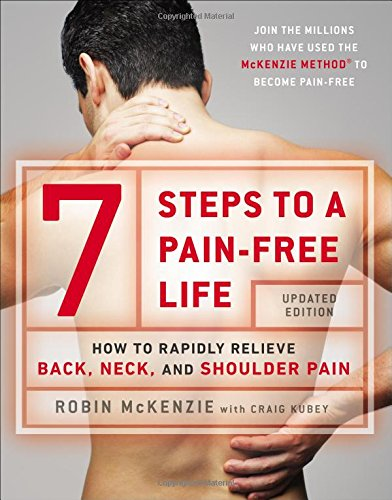Can this book help with other types of pain aside from back, neck, and shoulder? While the book focuses on back, neck, and shoulder pain, the principles of the McKenzie Method can be applied to other areas and may help alleviate different types of musculoskeletal pain. 